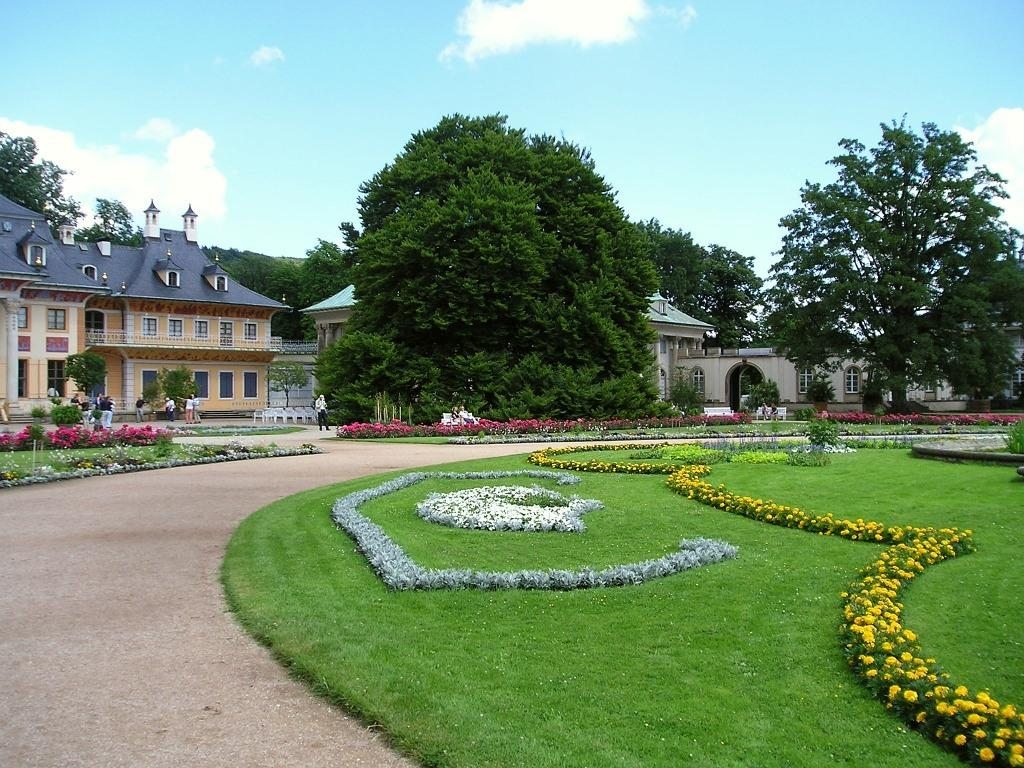What type of vegetation is present on the ground in the image? There is grass on the ground in the image. What other flora can be seen in the image? There are flowers on the grass. What can be seen in the background of the image? There are trees, buildings, and persons in the background of the image. Are there any flowers visible in the background? Yes, there are flowers in the background of the image. How would you describe the sky in the image? The sky is cloudy in the image. Can you tell me how many times the person in the background smiled in the image? There is no indication of anyone smiling in the image, so it cannot be determined. 